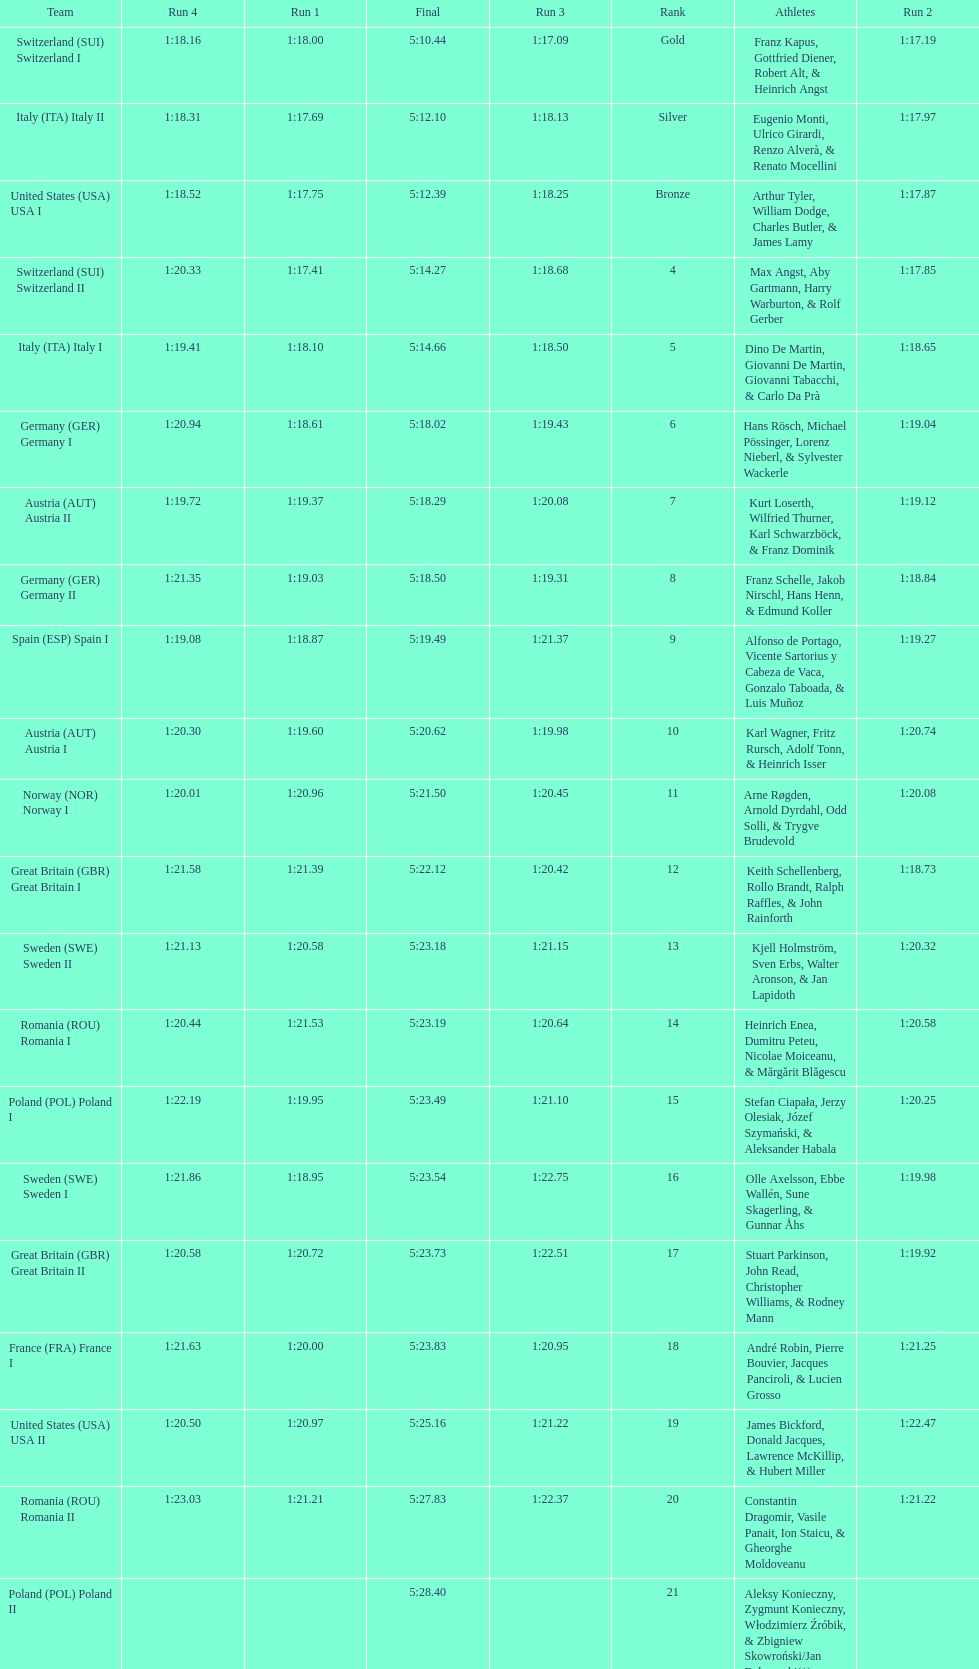After italy (ita) italy i, what team comes next? Germany I. 